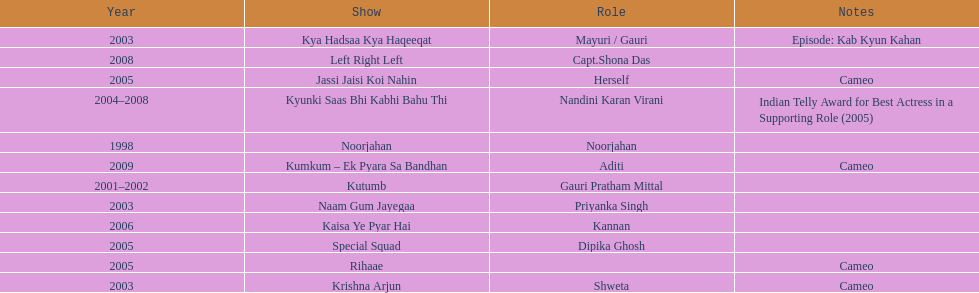How many shows were there in 2005? 3. 